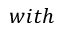Convert formula to latex. <formula><loc_0><loc_0><loc_500><loc_500>w i t h</formula> 